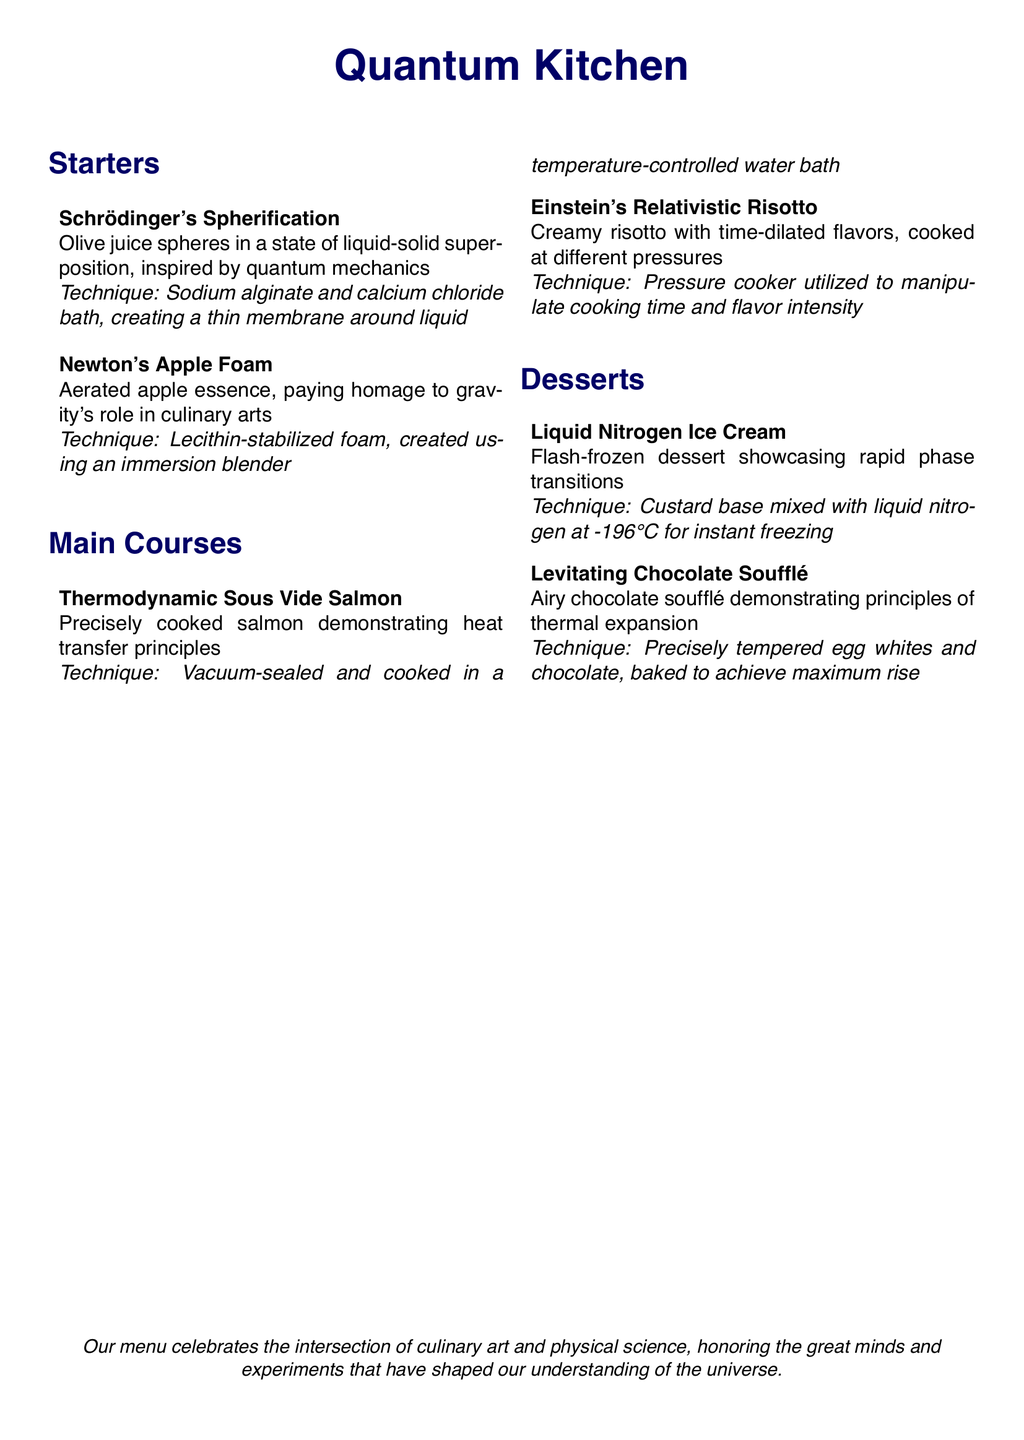What is the name of the restaurant? The title of the restaurant is indicated at the top of the document.
Answer: Quantum Kitchen What technique is used for Schrödinger's Spherification? The technique for this dish involves a specific method of food preparation mentioned in the document.
Answer: Sodium alginate and calcium chloride bath What type of dish is Newton's Apple Foam? This dish is categorized under the section for starters in the menu.
Answer: Starter Which scientific principle does the Thermodynamic Sous Vide Salmon demonstrate? The description explains that this dish showcases a certain concept related to heat transfer.
Answer: Heat transfer principles What temperature is liquid nitrogen at used for making ice cream? The document specifies the temperature of liquid nitrogen for the dessert preparation.
Answer: -196°C How are flavors manipulated in Einstein's Relativistic Risotto? The menu indicates a specific cooking tool and method that affects flavor intensity.
Answer: Pressure cooker What is the main culinary focus of the desserts section? The types of dishes included in this section suggest a theme related to a physical principle.
Answer: Phase transitions How does the Levitating Chocolate Soufflé achieve maximum rise? The technique described indicates a specific preparation step for achieving the soufflé's characteristic.
Answer: Precisely tempered egg whites and chocolate 